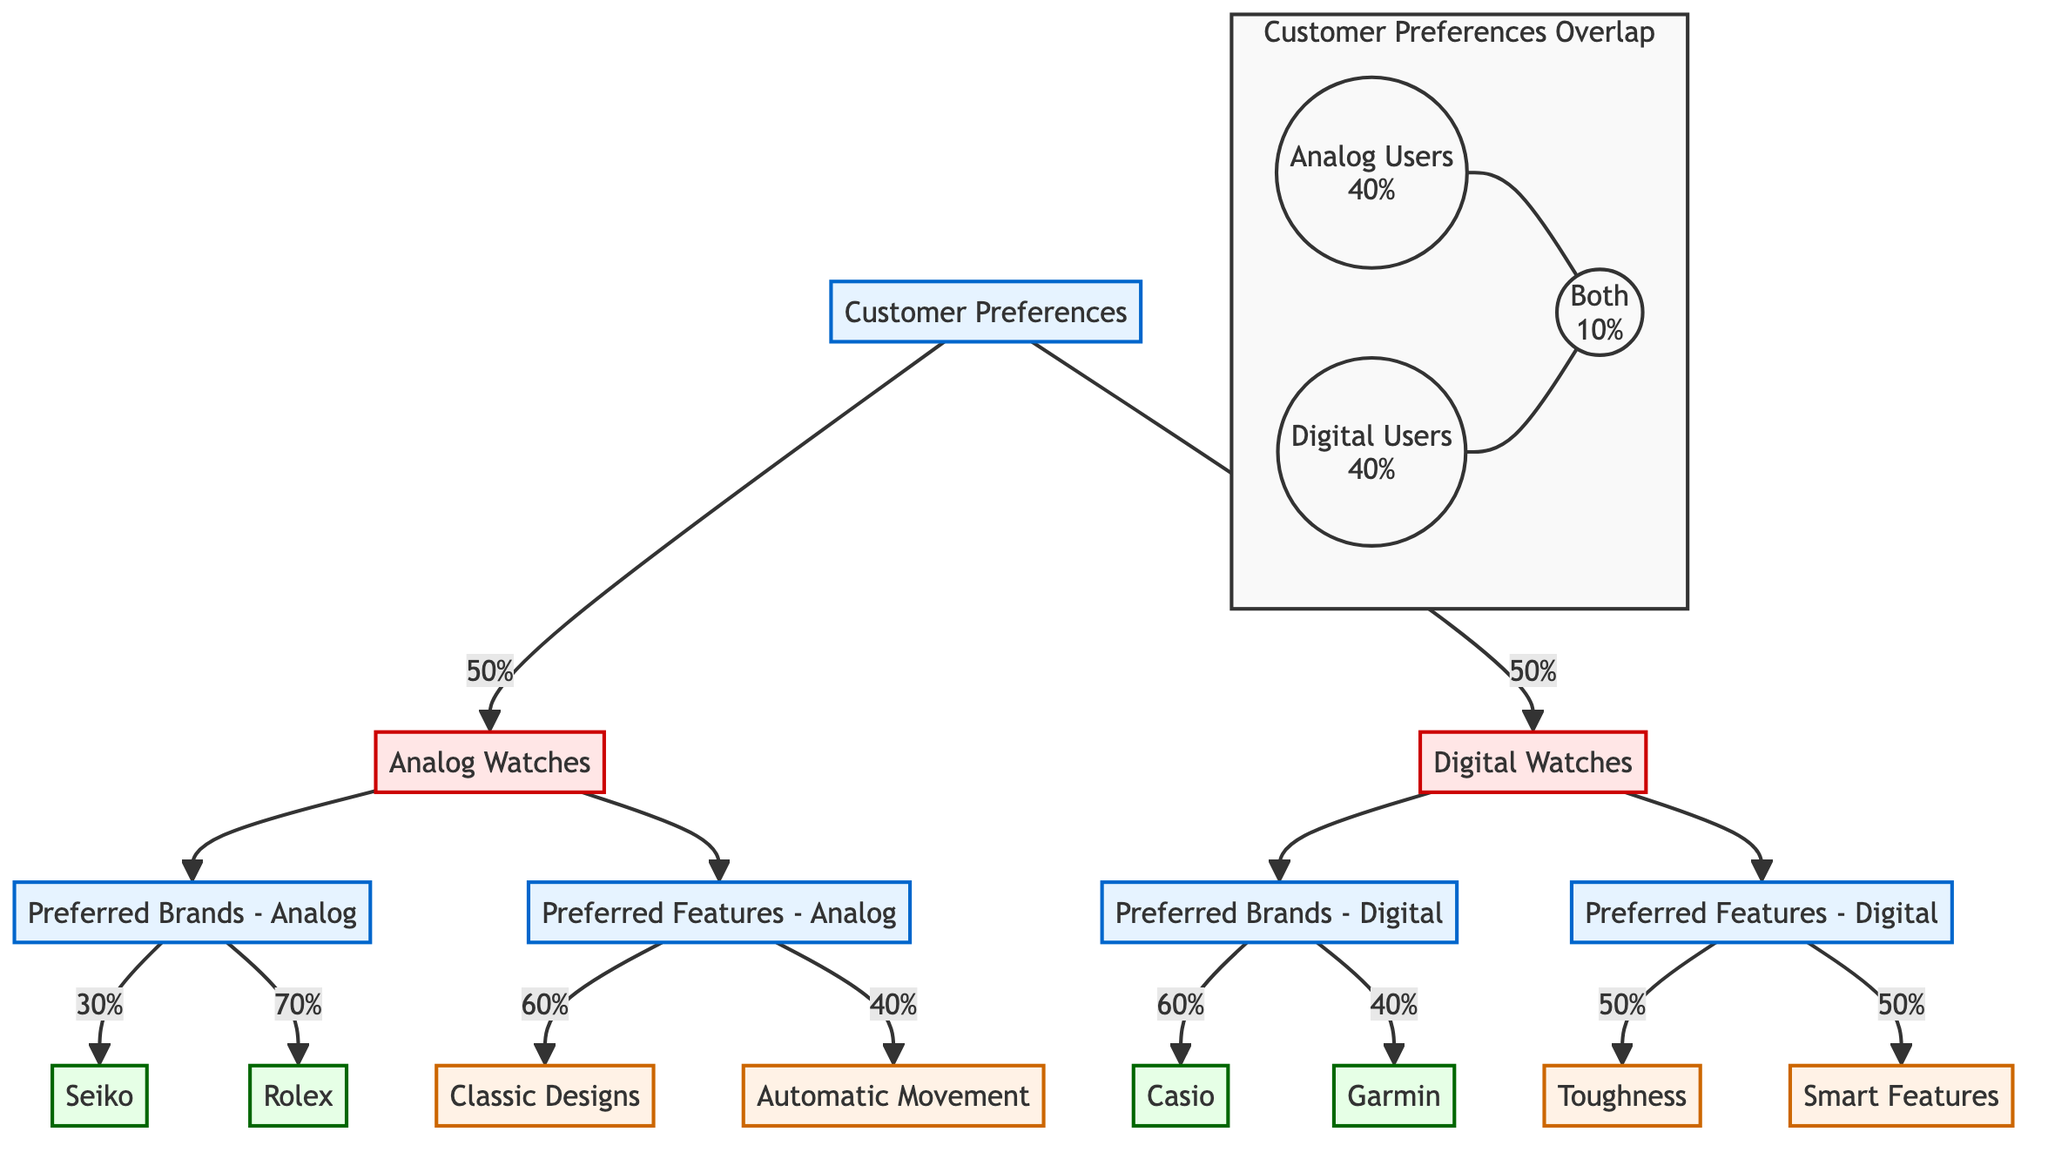What percentage of customers prefer Analog watches? The diagram shows a flow from "Customer Preferences" to "Analog Watches," indicating that 50% of customers prefer Analog watches.
Answer: 50% What are the preferred features of Digital watches? The diagram connects "Digital Watches" to "Preferred Features - Digital," from which two features are listed: "Smart Features" and "Toughness."
Answer: Smart Features, Toughness Which brand is the most preferred among Analog watch users? From the flowchart, "Preferred Brands - Analog" connects to "Seiko" and "Rolex," with "Rolex" receiving a larger percentage of 70%. Hence, it is the most preferred brand.
Answer: Rolex How many customers use both Analog and Digital watches? The Venn diagram section indicates that 10% of users fall into the category of "Both," representing customers who use both watch types.
Answer: 10% What is the proportion of customers preferring Automatic Movement in Analog watches? From "Preferred Features - Analog," there is a flow indicating 40% preference for "Automatic Movement," showing that not all features are equally popular.
Answer: 40% Which watch type has a higher preference among users? The flows from "Customer Preferences" show 50% preference for Analog watches and 50% for Digital watches, indicating that both types have equal customer preference.
Answer: Equal What percentage of Digital watch users prefer Toughness as a feature? Looking at the flow from "Preferred Features - Digital" leads to "Toughness," which shows that 50% of Digital watch users prefer this feature.
Answer: 50% How many preferred brands are shown for Analog watches? The diagram shows two brands linked to "Preferred Brands - Analog": "Seiko" and "Rolex," accounting for a total of two preferred brands in this category.
Answer: 2 What is the relationship between Analog Users and Digital Users in the Venn diagram? The Venn diagram indicates that "Analog Users" are represented as 40%, "Digital Users" also as 40%, with an overlap of 10%, illustrating the relationship between single and dual users.
Answer: Overlap of 10% 